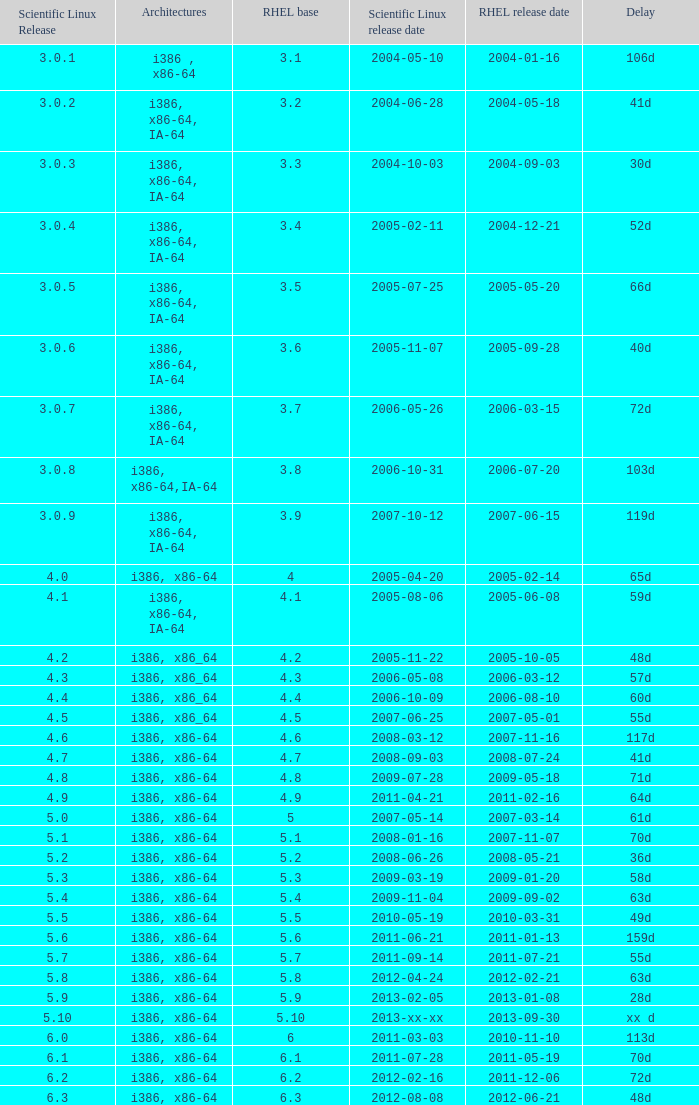What is the scientific linux edition when the deferral period is 28 days? 5.9. 